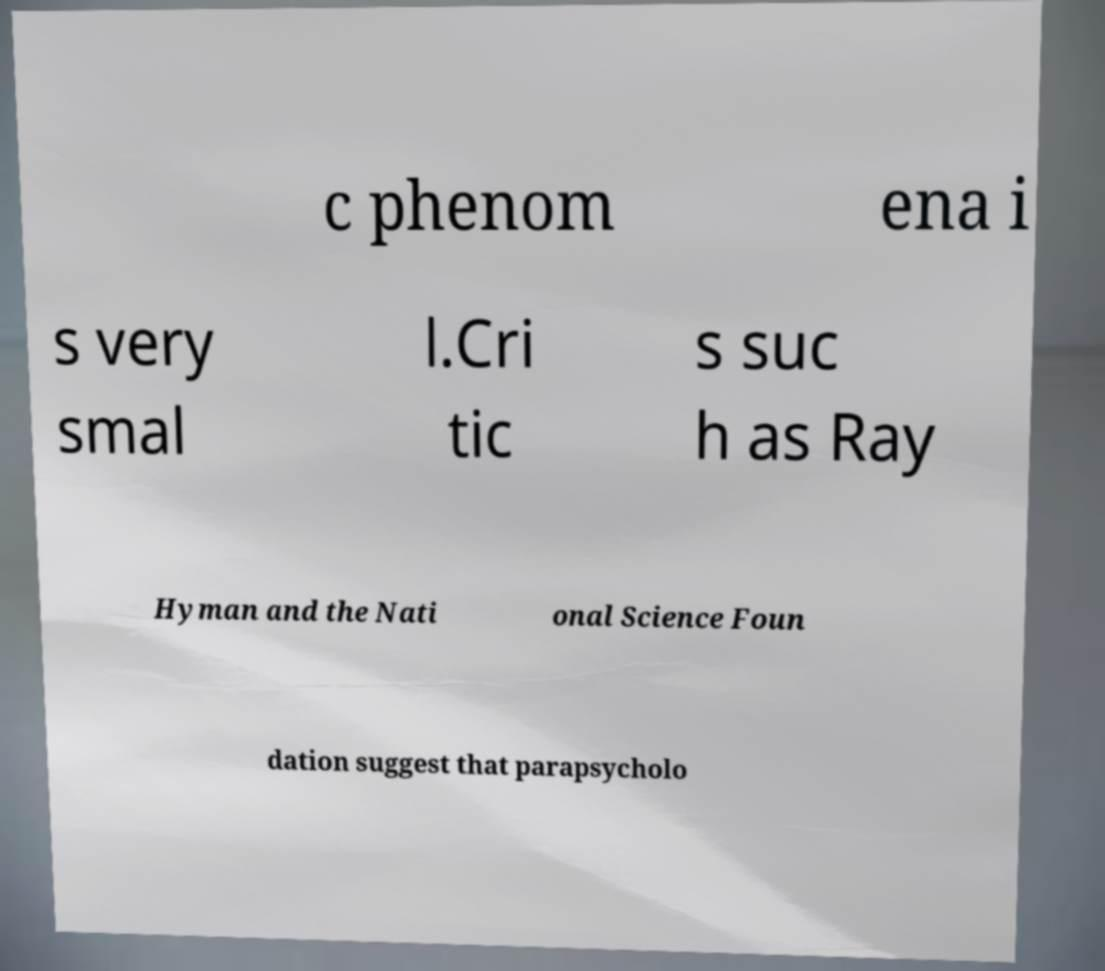For documentation purposes, I need the text within this image transcribed. Could you provide that? c phenom ena i s very smal l.Cri tic s suc h as Ray Hyman and the Nati onal Science Foun dation suggest that parapsycholo 